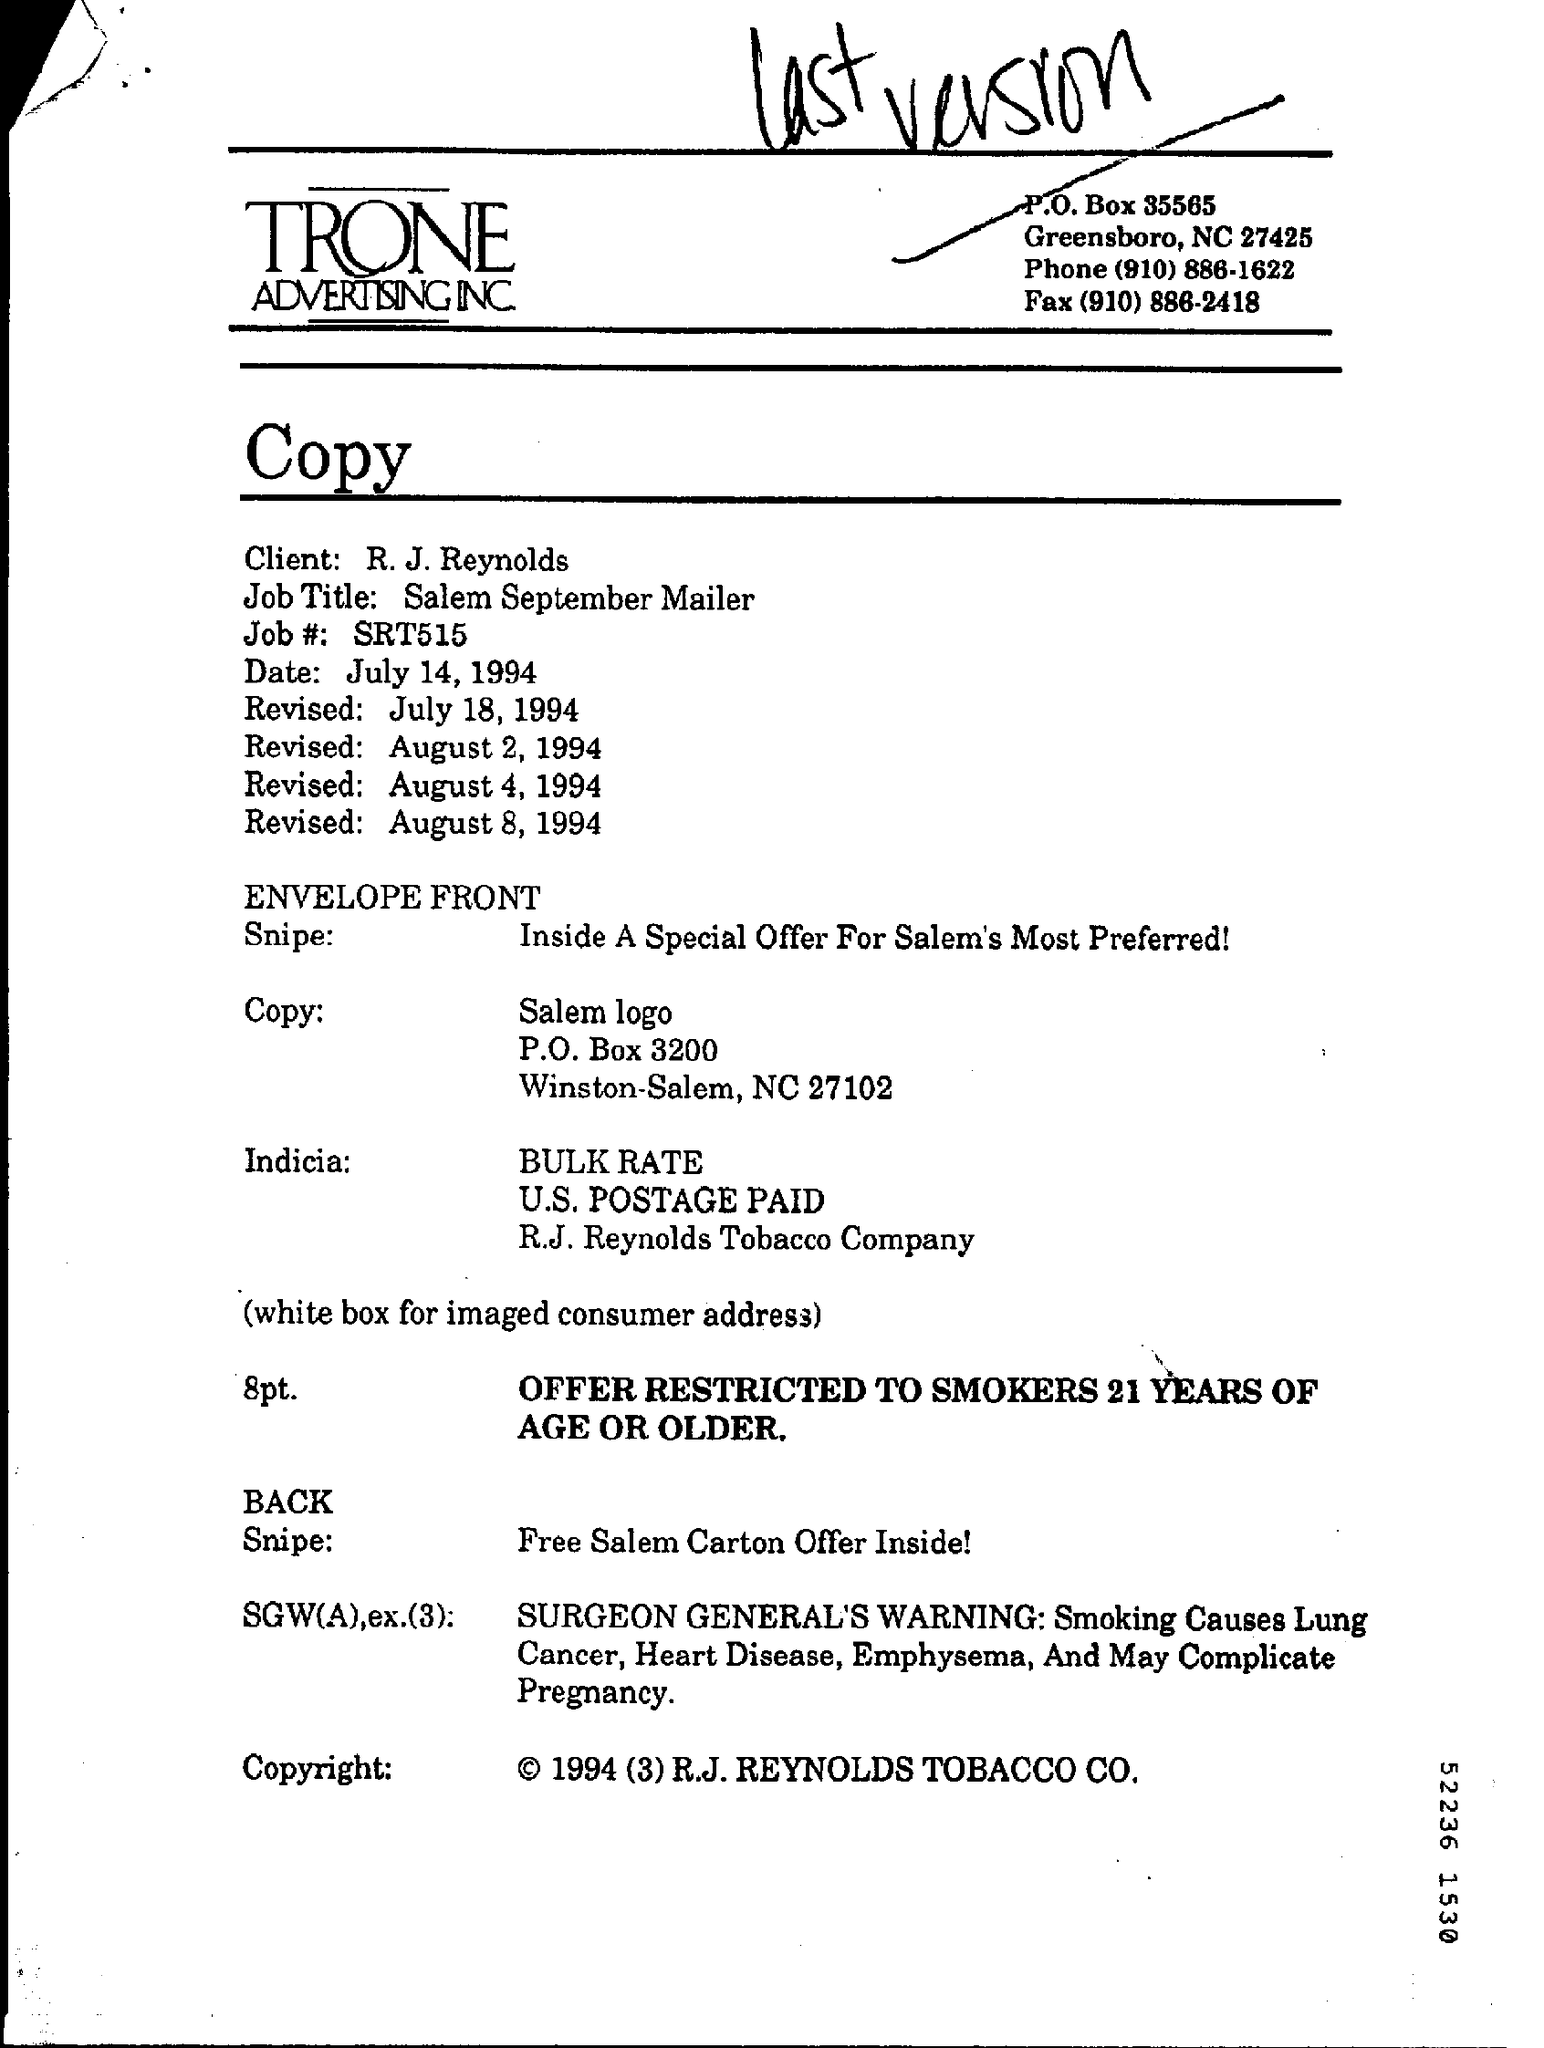Draw attention to some important aspects in this diagram. Trone Advertising Inc. is the company mentioned in the letter head. The client mentioned in the document is R. J. Reynolds. The job number provided in the document is SRT515. The job title mentioned in the document is 'Salem September Mailer.' 